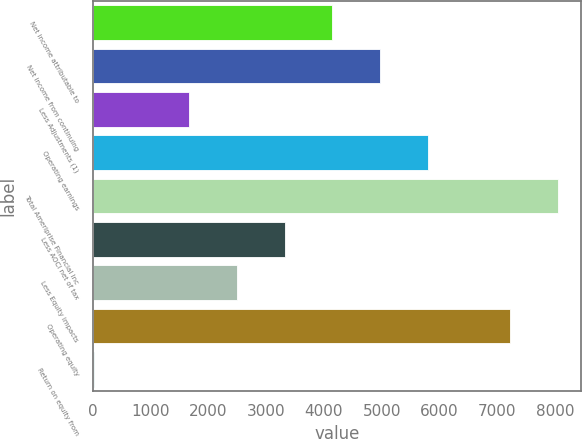<chart> <loc_0><loc_0><loc_500><loc_500><bar_chart><fcel>Net income attributable to<fcel>Net income from continuing<fcel>Less Adjustments (1)<fcel>Operating earnings<fcel>Total Ameriprise Financial Inc<fcel>Less AOCI net of tax<fcel>Less Equity impacts<fcel>Operating equity<fcel>Return on equity from<nl><fcel>4145.75<fcel>4970.6<fcel>1671.2<fcel>5795.45<fcel>8049.85<fcel>3320.9<fcel>2496.05<fcel>7225<fcel>21.5<nl></chart> 